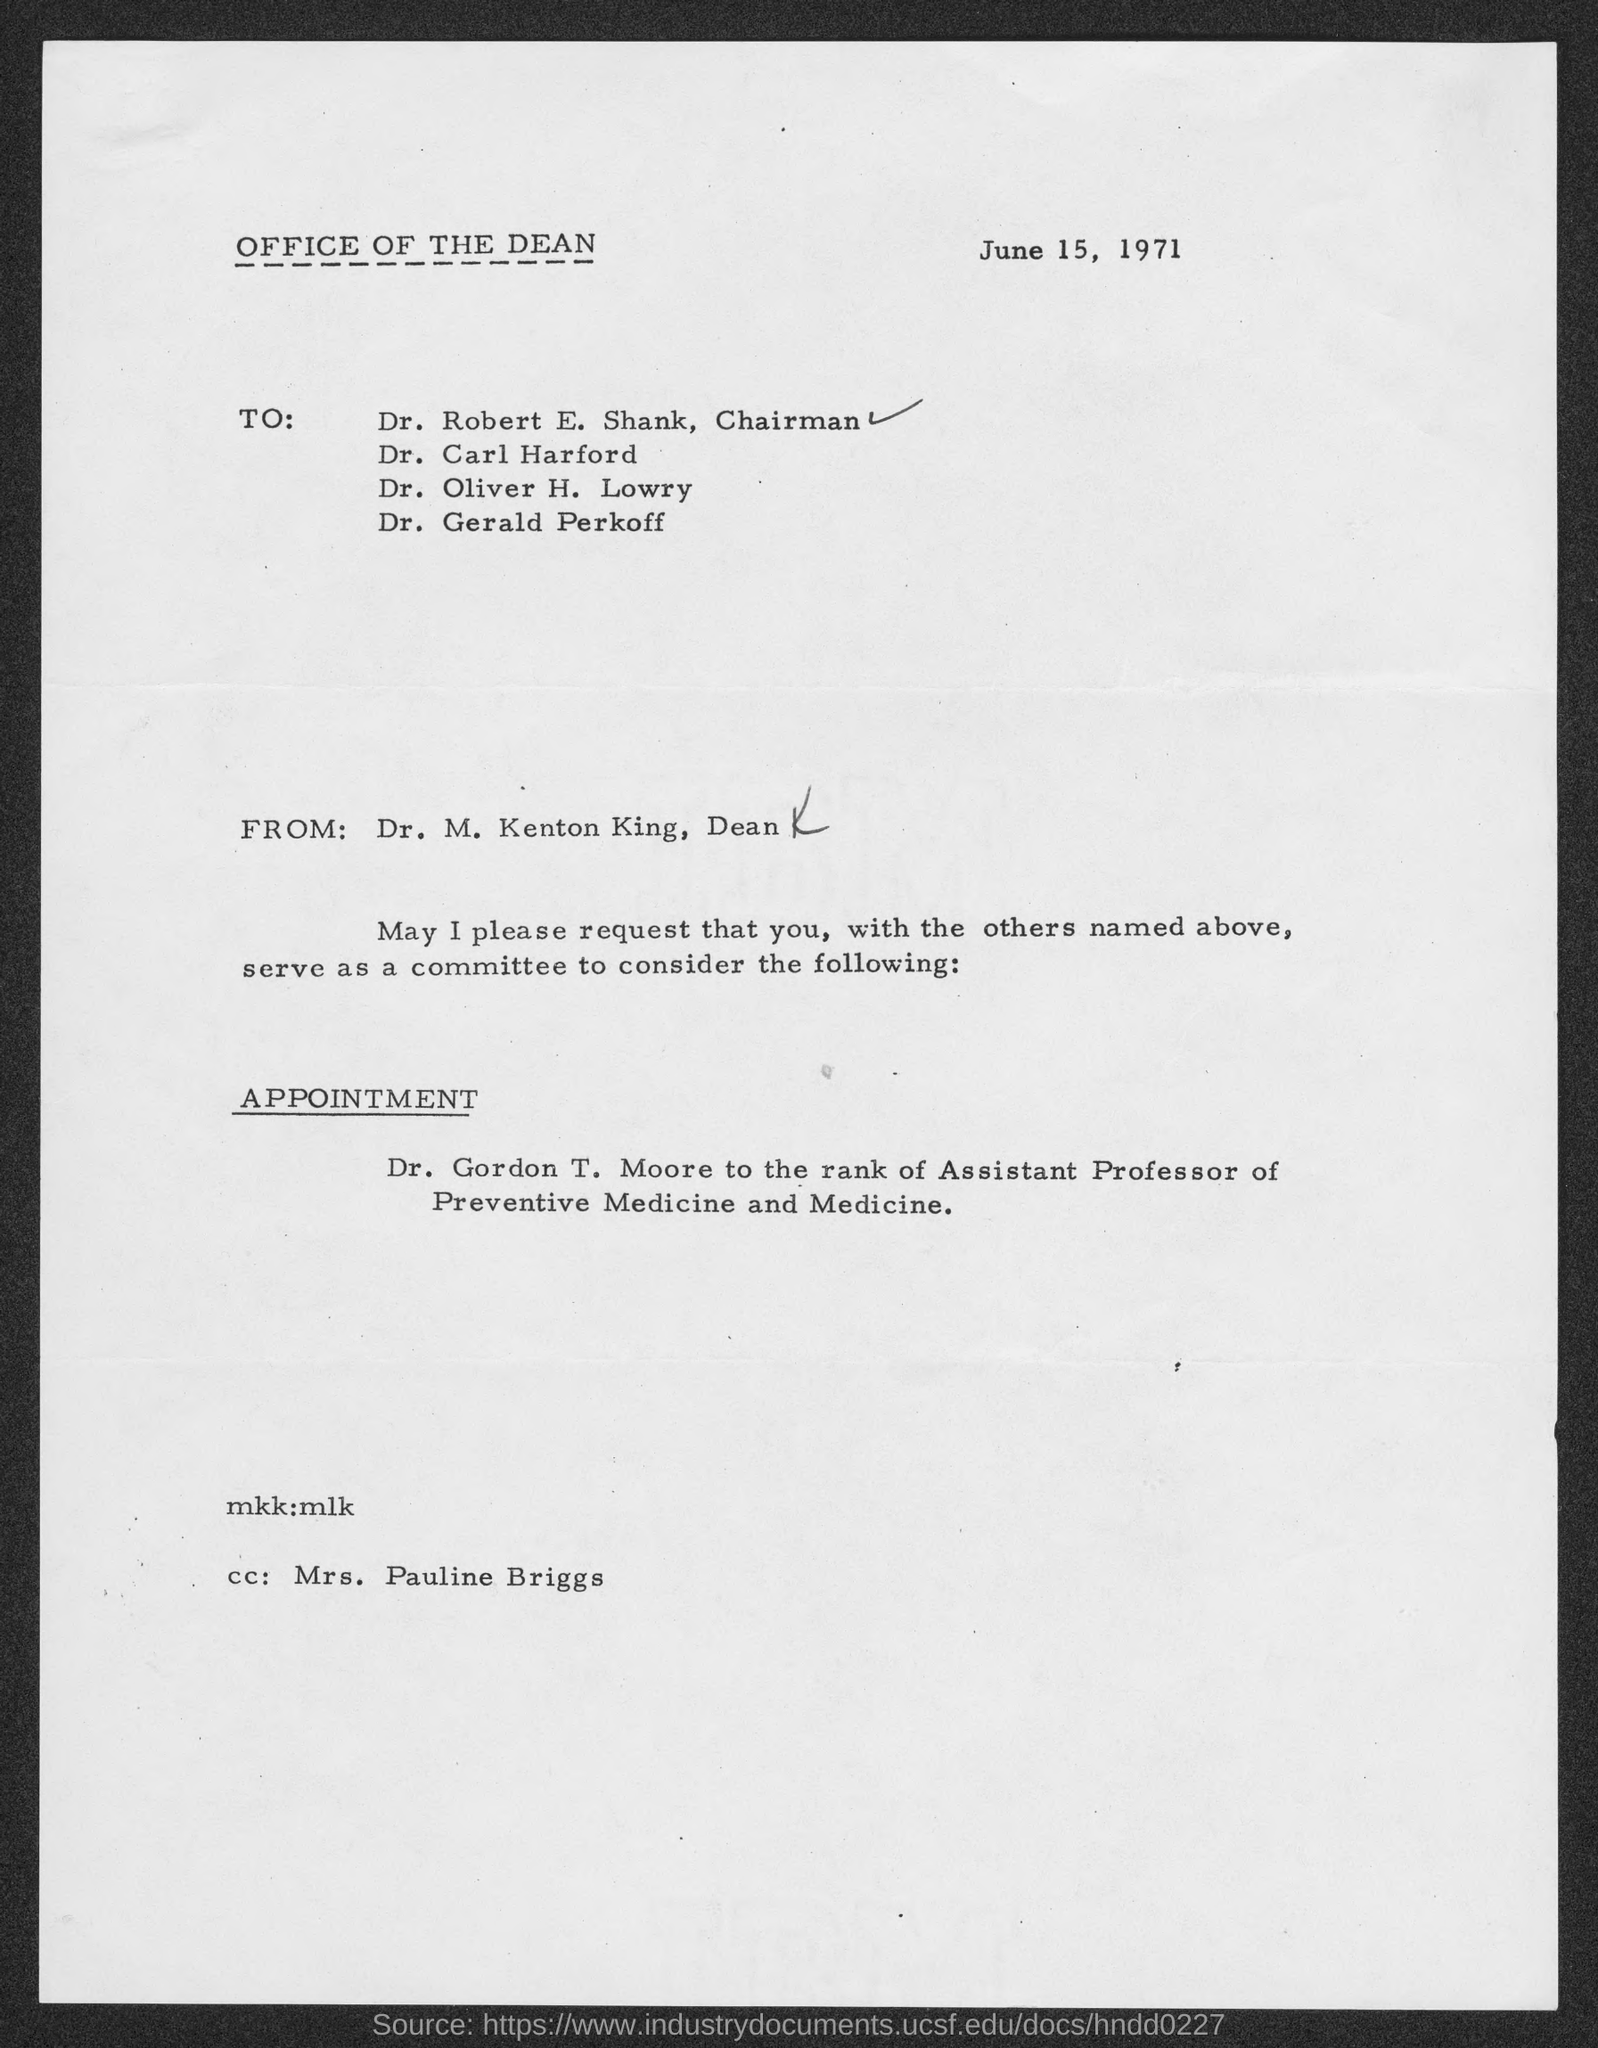Outline some significant characteristics in this image. The document is dated June 15, 1971. The letter is from Dr. M. Kenton King. Dr. Gordon T. Moore is considered to hold the rank of Assistant Professor of Preventive Medicine and Medicine. 